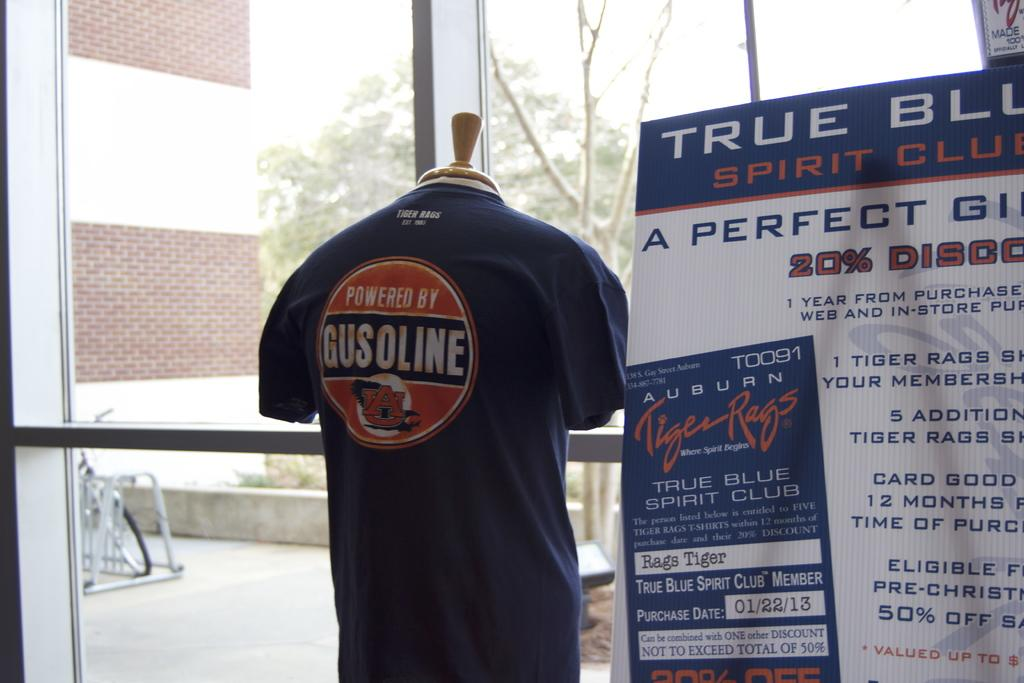Provide a one-sentence caption for the provided image. True Blue Spirit Club display and a Powered by Gusoline top. 